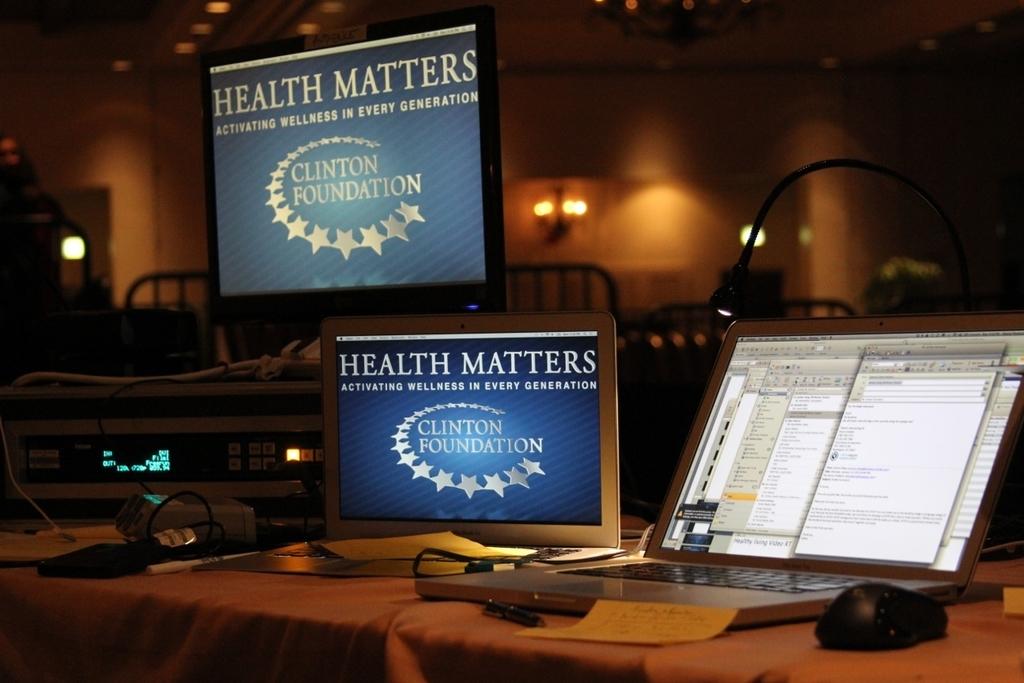What foundation is this?
Offer a terse response. Clinton. According to the slogan, what matters?
Keep it short and to the point. Health. 